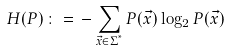<formula> <loc_0><loc_0><loc_500><loc_500>H ( P ) \, \colon = \, - \sum _ { \vec { x } \in \Sigma ^ { ^ { * } } } P ( \vec { x } ) \log _ { 2 } P ( \vec { x } )</formula> 